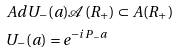<formula> <loc_0><loc_0><loc_500><loc_500>& A d U _ { - } ( a ) \mathcal { A } ( R _ { + } ) \subset A ( R _ { + } ) \\ & U _ { - } ( a ) = e ^ { - i P _ { - } a }</formula> 